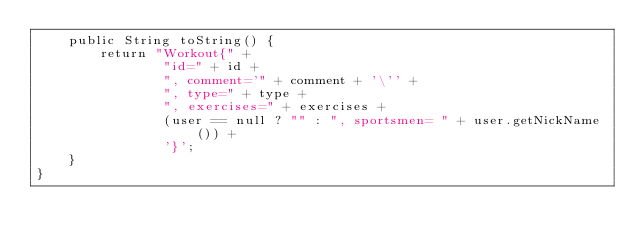Convert code to text. <code><loc_0><loc_0><loc_500><loc_500><_Java_>    public String toString() {
        return "Workout{" +
                "id=" + id +
                ", comment='" + comment + '\'' +
                ", type=" + type +
                ", exercises=" + exercises +
                (user == null ? "" : ", sportsmen= " + user.getNickName()) +
                '}';
    }
}
</code> 